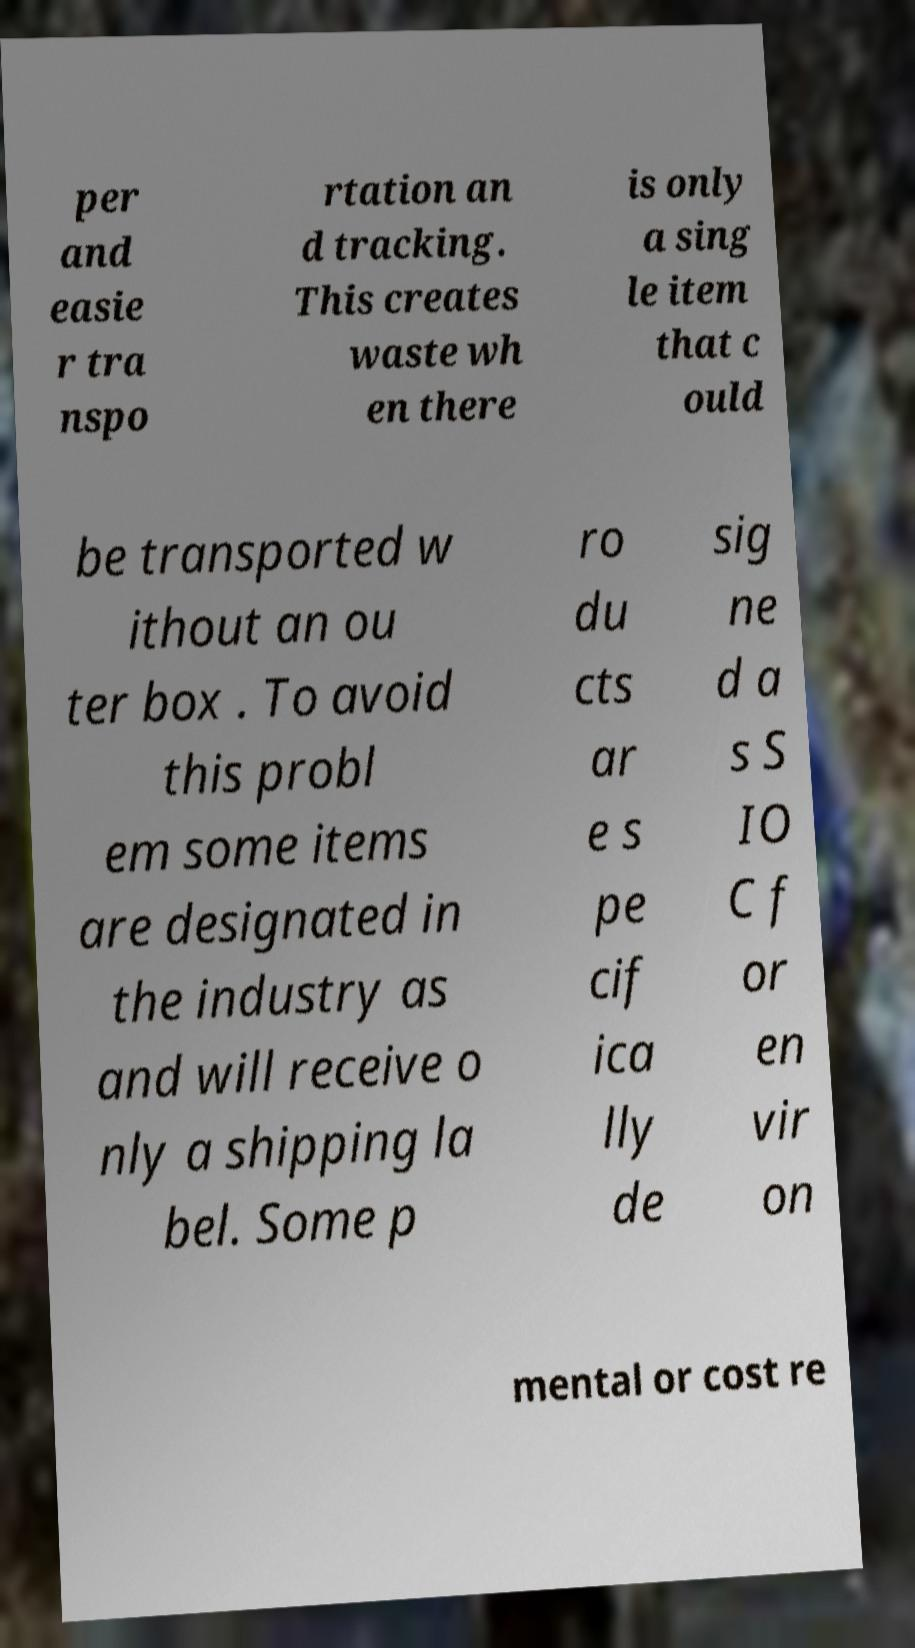Please identify and transcribe the text found in this image. per and easie r tra nspo rtation an d tracking. This creates waste wh en there is only a sing le item that c ould be transported w ithout an ou ter box . To avoid this probl em some items are designated in the industry as and will receive o nly a shipping la bel. Some p ro du cts ar e s pe cif ica lly de sig ne d a s S IO C f or en vir on mental or cost re 